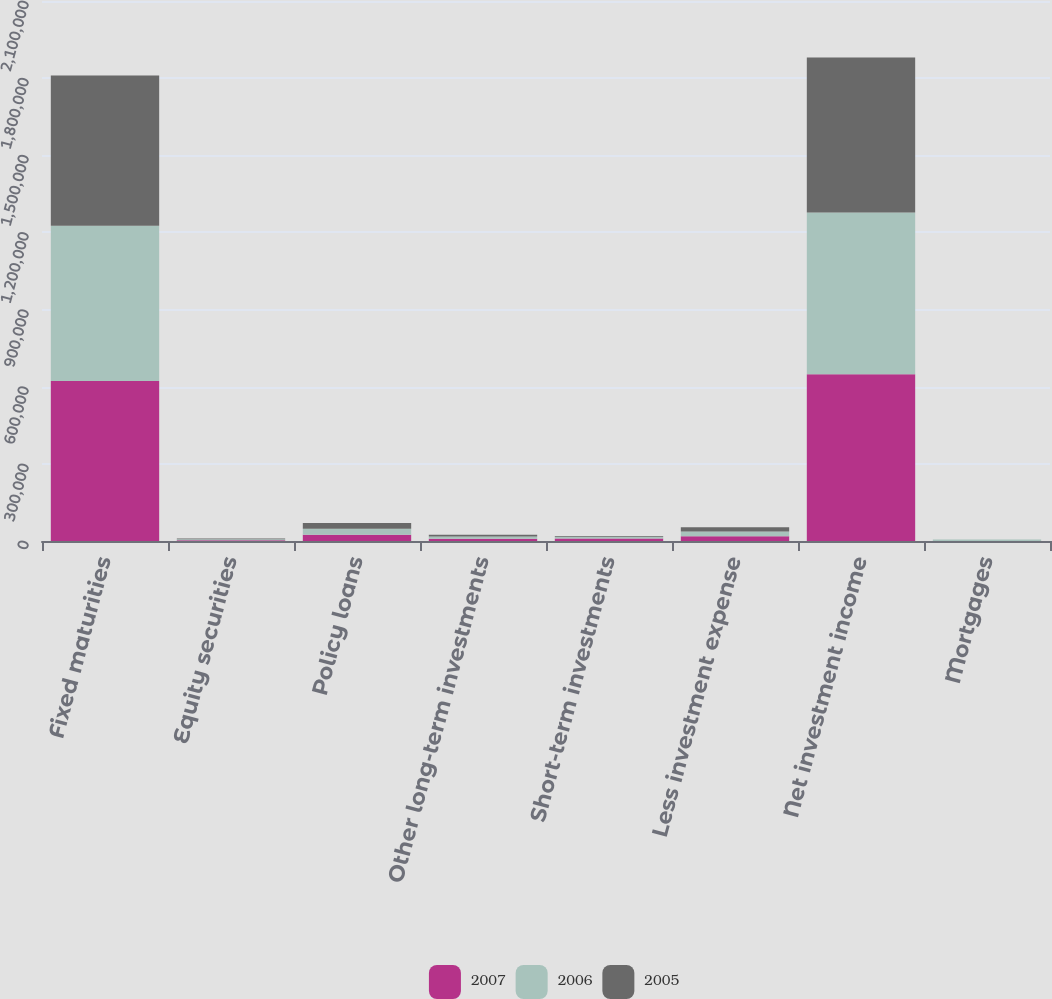Convert chart to OTSL. <chart><loc_0><loc_0><loc_500><loc_500><stacked_bar_chart><ecel><fcel>Fixed maturities<fcel>Equity securities<fcel>Policy loans<fcel>Other long-term investments<fcel>Short-term investments<fcel>Less investment expense<fcel>Net investment income<fcel>Mortgages<nl><fcel>2007<fcel>621752<fcel>2827<fcel>24344<fcel>8841<fcel>9379<fcel>18317<fcel>648826<fcel>0<nl><fcel>2006<fcel>604405<fcel>3503<fcel>23328<fcel>8731<fcel>6980<fcel>18201<fcel>628746<fcel>5783<nl><fcel>2005<fcel>584198<fcel>2986<fcel>22377<fcel>7117<fcel>2882<fcel>16492<fcel>603068<fcel>0<nl></chart> 